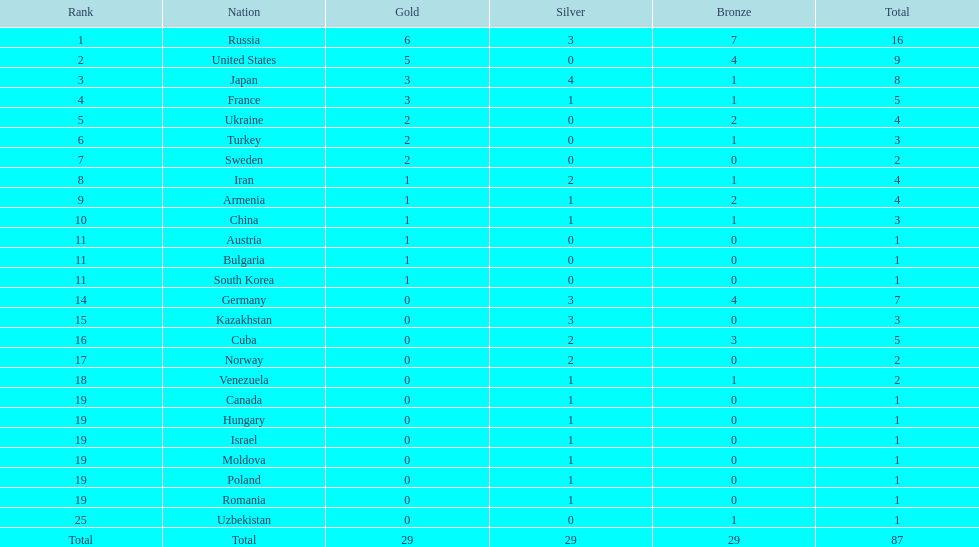Who held the position directly following turkey? Sweden. 